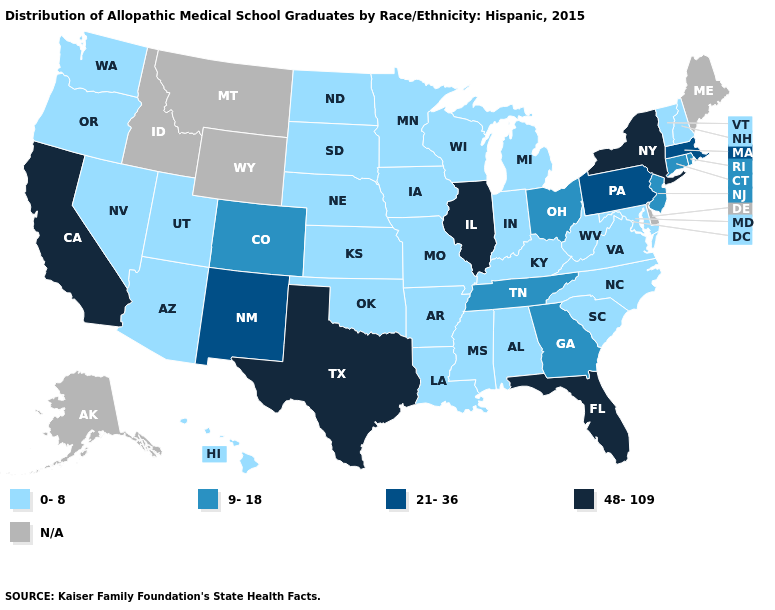Does New York have the lowest value in the Northeast?
Give a very brief answer. No. What is the highest value in the South ?
Quick response, please. 48-109. What is the value of West Virginia?
Concise answer only. 0-8. Does South Carolina have the lowest value in the South?
Answer briefly. Yes. Name the states that have a value in the range 48-109?
Concise answer only. California, Florida, Illinois, New York, Texas. Among the states that border Massachusetts , does New Hampshire have the highest value?
Give a very brief answer. No. Name the states that have a value in the range 0-8?
Write a very short answer. Alabama, Arizona, Arkansas, Hawaii, Indiana, Iowa, Kansas, Kentucky, Louisiana, Maryland, Michigan, Minnesota, Mississippi, Missouri, Nebraska, Nevada, New Hampshire, North Carolina, North Dakota, Oklahoma, Oregon, South Carolina, South Dakota, Utah, Vermont, Virginia, Washington, West Virginia, Wisconsin. Among the states that border Louisiana , does Texas have the highest value?
Short answer required. Yes. Among the states that border California , which have the highest value?
Give a very brief answer. Arizona, Nevada, Oregon. What is the lowest value in the South?
Concise answer only. 0-8. Among the states that border Indiana , which have the lowest value?
Answer briefly. Kentucky, Michigan. What is the value of Ohio?
Give a very brief answer. 9-18. Which states have the lowest value in the USA?
Answer briefly. Alabama, Arizona, Arkansas, Hawaii, Indiana, Iowa, Kansas, Kentucky, Louisiana, Maryland, Michigan, Minnesota, Mississippi, Missouri, Nebraska, Nevada, New Hampshire, North Carolina, North Dakota, Oklahoma, Oregon, South Carolina, South Dakota, Utah, Vermont, Virginia, Washington, West Virginia, Wisconsin. 